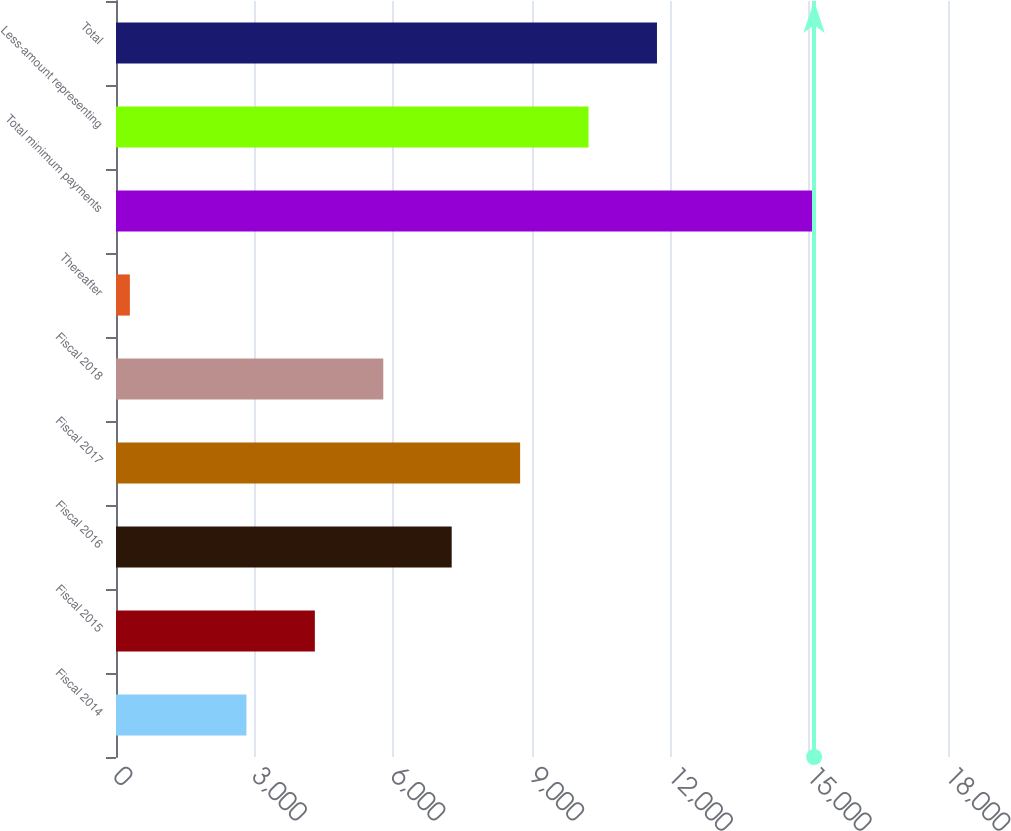<chart> <loc_0><loc_0><loc_500><loc_500><bar_chart><fcel>Fiscal 2014<fcel>Fiscal 2015<fcel>Fiscal 2016<fcel>Fiscal 2017<fcel>Fiscal 2018<fcel>Thereafter<fcel>Total minimum payments<fcel>Less-amount representing<fcel>Total<nl><fcel>2822<fcel>4302.3<fcel>7262.9<fcel>8743.2<fcel>5782.6<fcel>300<fcel>15103<fcel>10223.5<fcel>11703.8<nl></chart> 